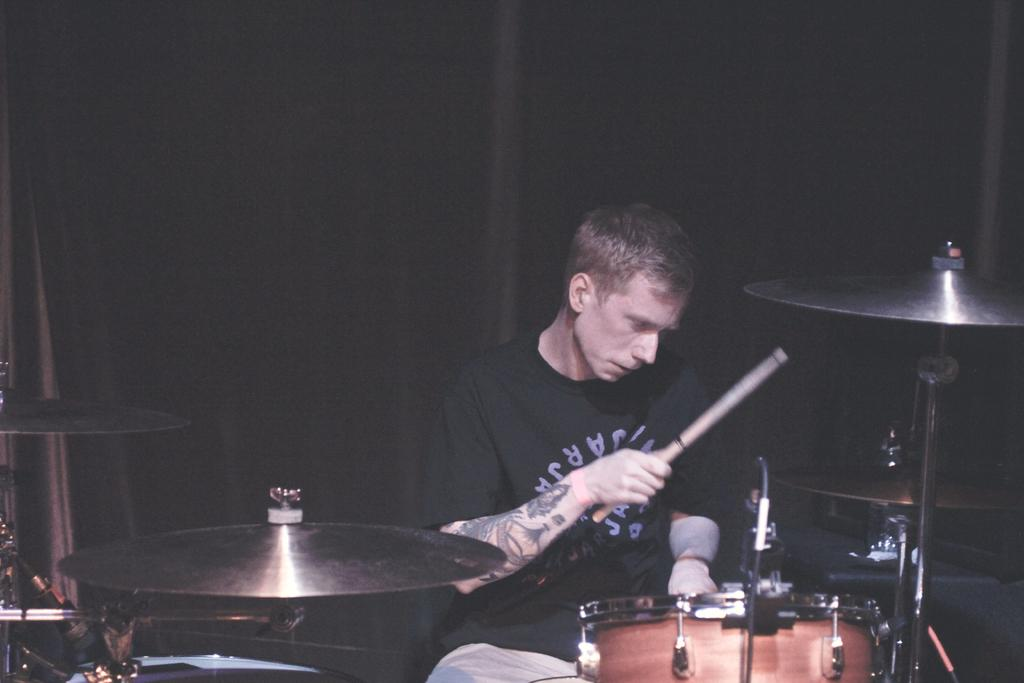Who or what is present in the image? There is a person in the image. What is the person holding in the image? The person is holding a stick. What musical instrument can be seen in the image? There is a drum kit in the image. What is the color of the background in the image? The background of the image is dark. What type of mint is growing near the drum kit in the image? There is no mint present in the image; it only features a person holding a stick, a drum kit, and a dark background. 